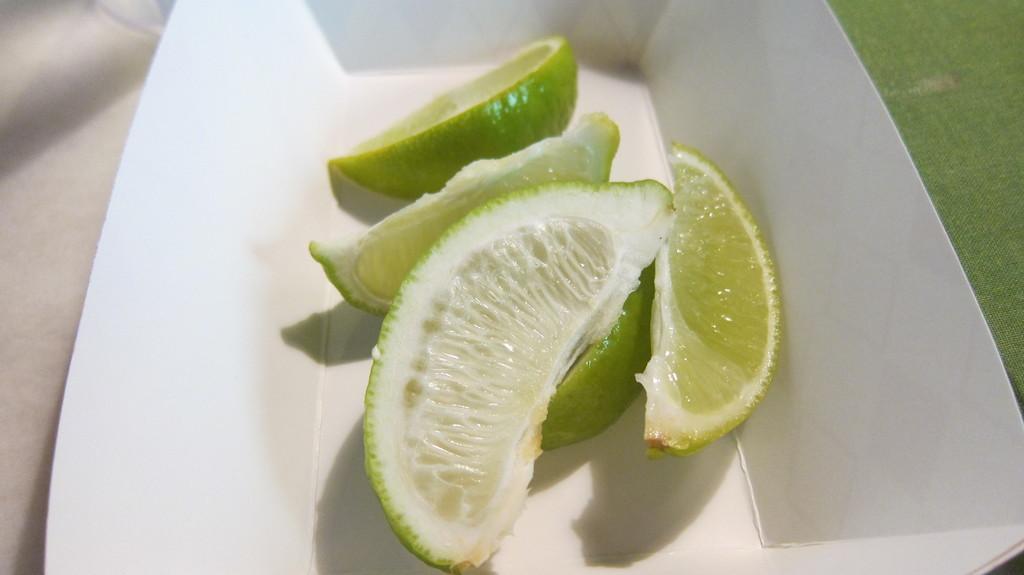In one or two sentences, can you explain what this image depicts? In this image we can see the Persian lime pieces in the white box which is on the surface. 